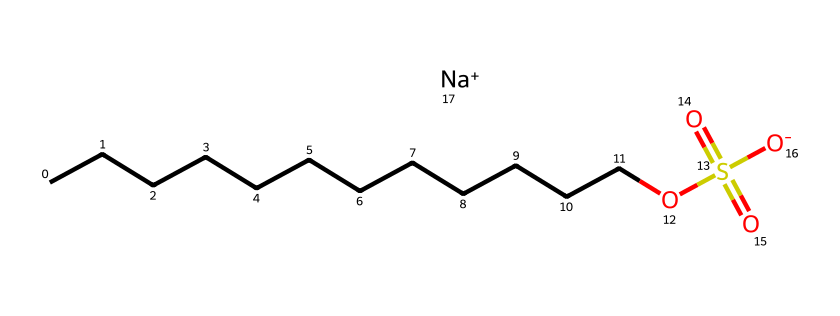What is the total number of carbon atoms in sodium lauryl sulfate? The SMILES representation shows a continuous chain of carbon atoms represented by "CCCCCCCCCCCC," which indicates there are 12 carbon atoms in total.
Answer: 12 What functional groups are present in sodium lauryl sulfate? The structure includes a sulfonate group "OS(=O)(=O)" and a hydrocarbon chain, confirming the presence of a sulfate as the functional group.
Answer: sulfate How many oxygen atoms are in the chemical structure of sodium lauryl sulfate? The SMILES representation shows two oxygen atoms in the sulfonate group "(=O)(=O)" and one more from the hydroxy group "O," resulting in a total of three oxygen atoms.
Answer: 3 What is the role of sodium in sodium lauryl sulfate? Sodium is represented as "[Na+]" and acts as a counterion to balance the negative charge of the sulfonate group, making the compound a salt.
Answer: counterion Why is sodium lauryl sulfate considered an effective detergent? The long hydrophobic hydrocarbon tail interacts with oils and dirt, while the hydrophilic sulfonate group allows interaction with water, enabling emulsification and cleansing properties.
Answer: emulsification Indicate the charge of the sulfate group in sodium lauryl sulfate. The presence of "[O-]" indicates a negative charge on the sulfonate group, confirming that it is negatively charged in its ionic form.
Answer: negative What is the significance of the hydrocarbon chain length in sodium lauryl sulfate? The length of the hydrocarbon chain (12 carbons) contributes to its hydrophobic characteristics, enhancing its ability to interact with and remove dirt and grease.
Answer: hydrophobic characteristics 